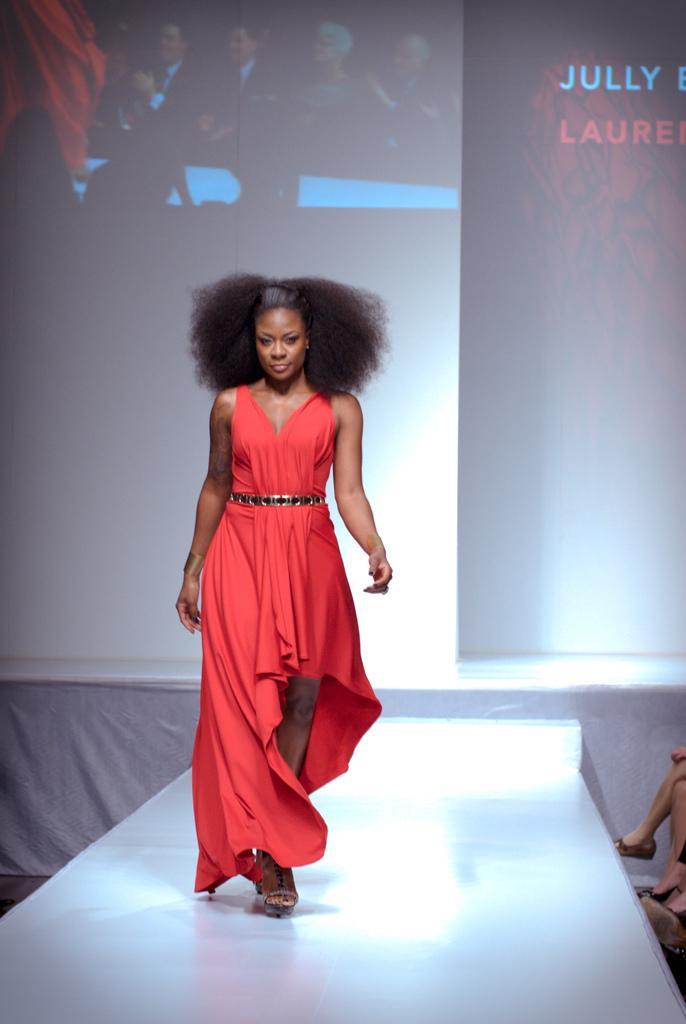Could you give a brief overview of what you see in this image? There is one woman walking on the ramp as we can see in the middle of this image and we can see a screen in the background. 